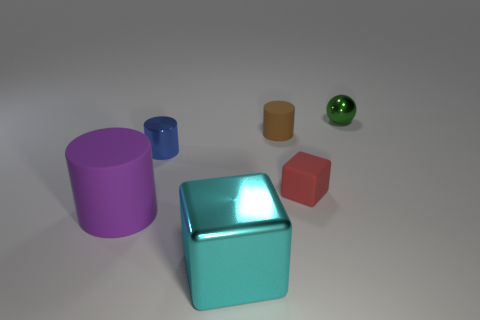Add 4 tiny rubber cubes. How many objects exist? 10 Subtract all blocks. How many objects are left? 4 Subtract all small blue metal objects. Subtract all brown cylinders. How many objects are left? 4 Add 6 large cyan blocks. How many large cyan blocks are left? 7 Add 2 red things. How many red things exist? 3 Subtract 0 cyan cylinders. How many objects are left? 6 